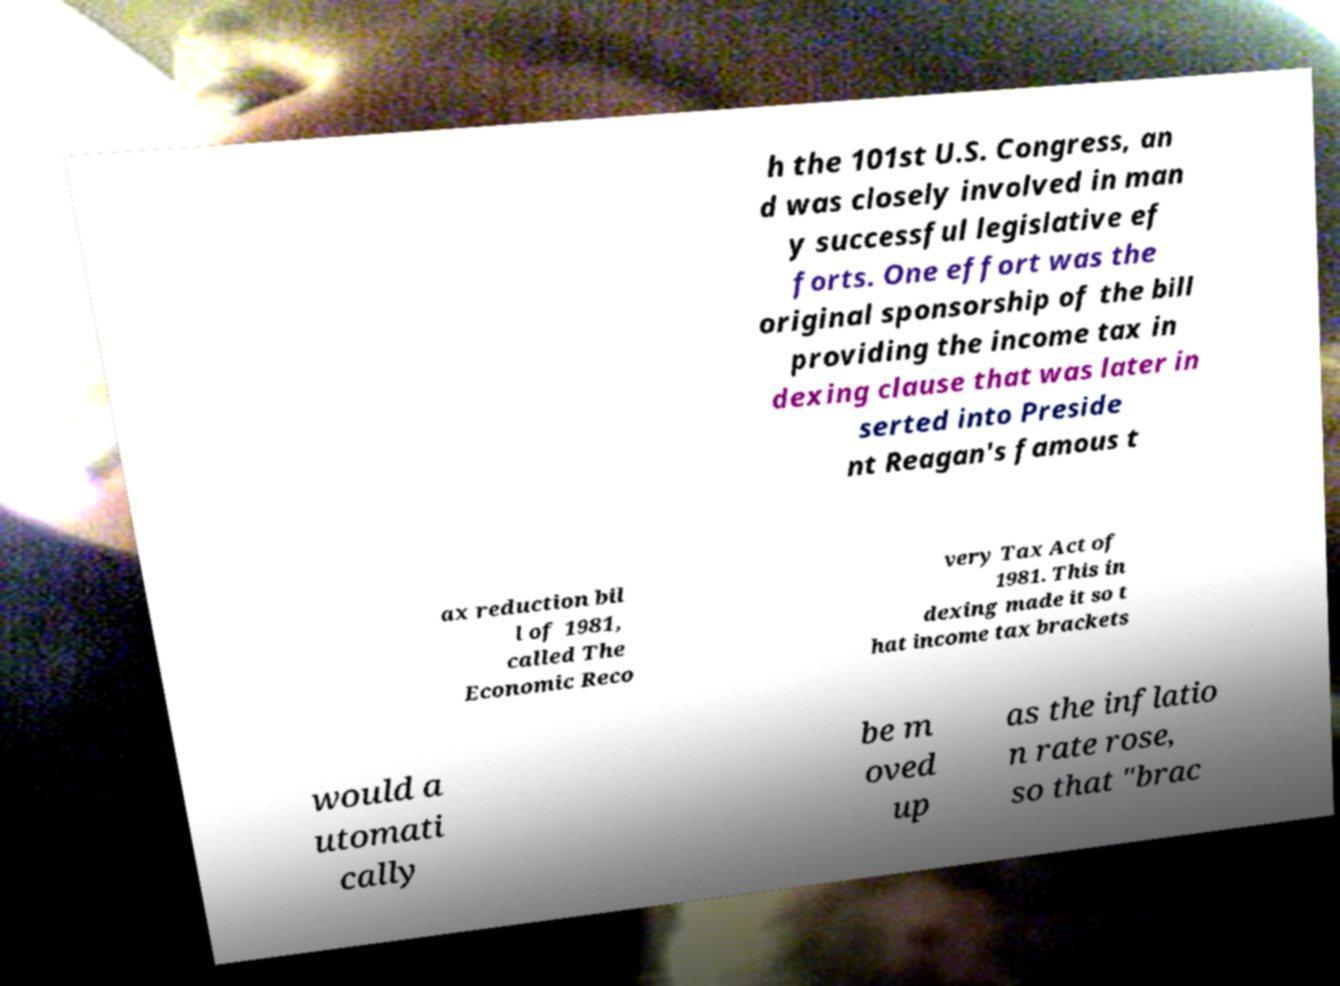Could you assist in decoding the text presented in this image and type it out clearly? h the 101st U.S. Congress, an d was closely involved in man y successful legislative ef forts. One effort was the original sponsorship of the bill providing the income tax in dexing clause that was later in serted into Preside nt Reagan's famous t ax reduction bil l of 1981, called The Economic Reco very Tax Act of 1981. This in dexing made it so t hat income tax brackets would a utomati cally be m oved up as the inflatio n rate rose, so that "brac 